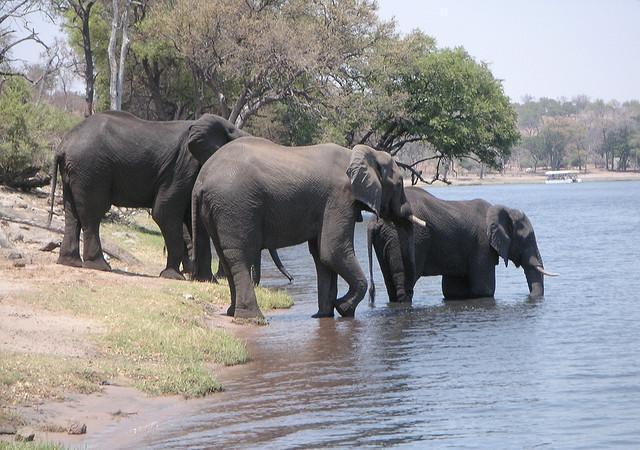How many elephants are in the water?
Give a very brief answer. 2. How many tails can you see in this picture?
Give a very brief answer. 3. How many elephants can be seen?
Give a very brief answer. 3. 